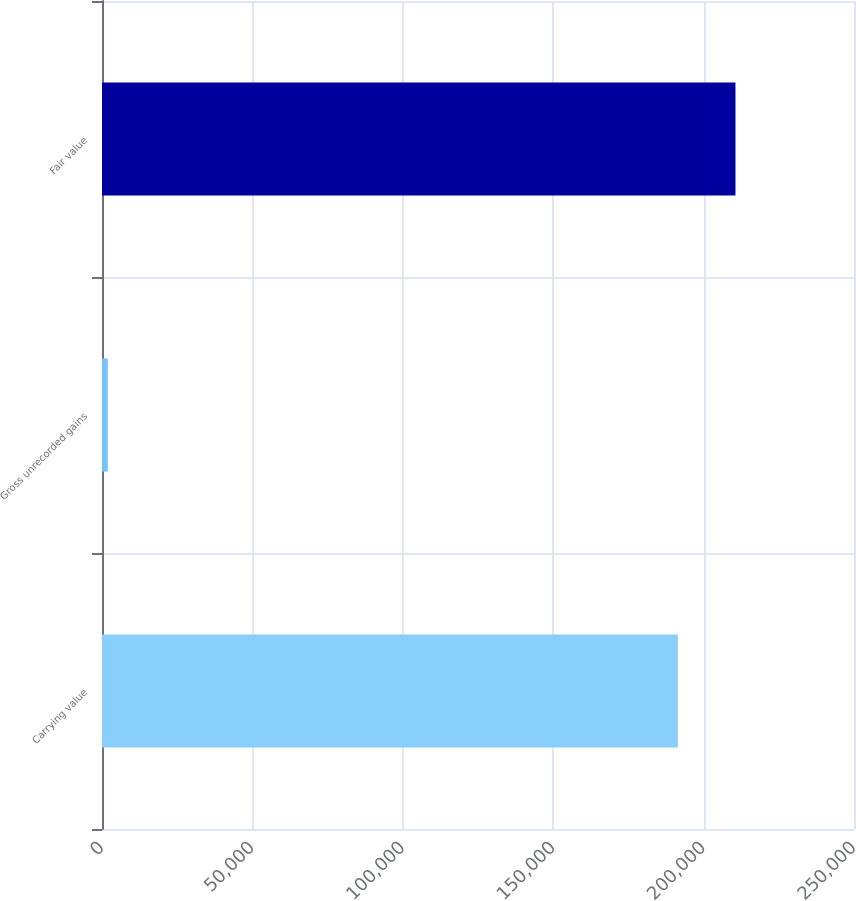Convert chart. <chart><loc_0><loc_0><loc_500><loc_500><bar_chart><fcel>Carrying value<fcel>Gross unrecorded gains<fcel>Fair value<nl><fcel>191450<fcel>1913<fcel>210595<nl></chart> 